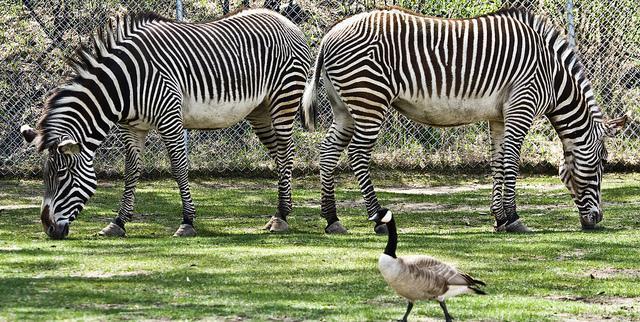How many zebras can be seen?
Give a very brief answer. 2. 